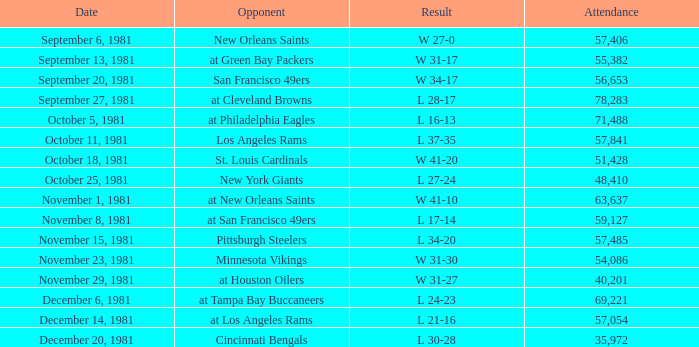On what date did the team play againt the New Orleans Saints? September 6, 1981. Parse the full table. {'header': ['Date', 'Opponent', 'Result', 'Attendance'], 'rows': [['September 6, 1981', 'New Orleans Saints', 'W 27-0', '57,406'], ['September 13, 1981', 'at Green Bay Packers', 'W 31-17', '55,382'], ['September 20, 1981', 'San Francisco 49ers', 'W 34-17', '56,653'], ['September 27, 1981', 'at Cleveland Browns', 'L 28-17', '78,283'], ['October 5, 1981', 'at Philadelphia Eagles', 'L 16-13', '71,488'], ['October 11, 1981', 'Los Angeles Rams', 'L 37-35', '57,841'], ['October 18, 1981', 'St. Louis Cardinals', 'W 41-20', '51,428'], ['October 25, 1981', 'New York Giants', 'L 27-24', '48,410'], ['November 1, 1981', 'at New Orleans Saints', 'W 41-10', '63,637'], ['November 8, 1981', 'at San Francisco 49ers', 'L 17-14', '59,127'], ['November 15, 1981', 'Pittsburgh Steelers', 'L 34-20', '57,485'], ['November 23, 1981', 'Minnesota Vikings', 'W 31-30', '54,086'], ['November 29, 1981', 'at Houston Oilers', 'W 31-27', '40,201'], ['December 6, 1981', 'at Tampa Bay Buccaneers', 'L 24-23', '69,221'], ['December 14, 1981', 'at Los Angeles Rams', 'L 21-16', '57,054'], ['December 20, 1981', 'Cincinnati Bengals', 'L 30-28', '35,972']]} 